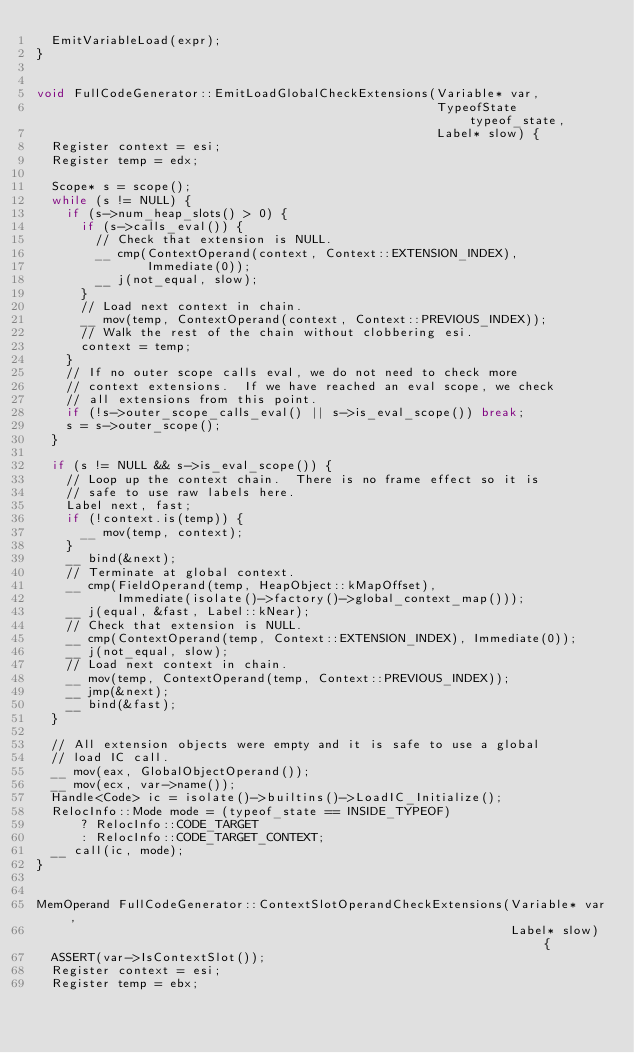<code> <loc_0><loc_0><loc_500><loc_500><_C++_>  EmitVariableLoad(expr);
}


void FullCodeGenerator::EmitLoadGlobalCheckExtensions(Variable* var,
                                                      TypeofState typeof_state,
                                                      Label* slow) {
  Register context = esi;
  Register temp = edx;

  Scope* s = scope();
  while (s != NULL) {
    if (s->num_heap_slots() > 0) {
      if (s->calls_eval()) {
        // Check that extension is NULL.
        __ cmp(ContextOperand(context, Context::EXTENSION_INDEX),
               Immediate(0));
        __ j(not_equal, slow);
      }
      // Load next context in chain.
      __ mov(temp, ContextOperand(context, Context::PREVIOUS_INDEX));
      // Walk the rest of the chain without clobbering esi.
      context = temp;
    }
    // If no outer scope calls eval, we do not need to check more
    // context extensions.  If we have reached an eval scope, we check
    // all extensions from this point.
    if (!s->outer_scope_calls_eval() || s->is_eval_scope()) break;
    s = s->outer_scope();
  }

  if (s != NULL && s->is_eval_scope()) {
    // Loop up the context chain.  There is no frame effect so it is
    // safe to use raw labels here.
    Label next, fast;
    if (!context.is(temp)) {
      __ mov(temp, context);
    }
    __ bind(&next);
    // Terminate at global context.
    __ cmp(FieldOperand(temp, HeapObject::kMapOffset),
           Immediate(isolate()->factory()->global_context_map()));
    __ j(equal, &fast, Label::kNear);
    // Check that extension is NULL.
    __ cmp(ContextOperand(temp, Context::EXTENSION_INDEX), Immediate(0));
    __ j(not_equal, slow);
    // Load next context in chain.
    __ mov(temp, ContextOperand(temp, Context::PREVIOUS_INDEX));
    __ jmp(&next);
    __ bind(&fast);
  }

  // All extension objects were empty and it is safe to use a global
  // load IC call.
  __ mov(eax, GlobalObjectOperand());
  __ mov(ecx, var->name());
  Handle<Code> ic = isolate()->builtins()->LoadIC_Initialize();
  RelocInfo::Mode mode = (typeof_state == INSIDE_TYPEOF)
      ? RelocInfo::CODE_TARGET
      : RelocInfo::CODE_TARGET_CONTEXT;
  __ call(ic, mode);
}


MemOperand FullCodeGenerator::ContextSlotOperandCheckExtensions(Variable* var,
                                                                Label* slow) {
  ASSERT(var->IsContextSlot());
  Register context = esi;
  Register temp = ebx;
</code> 